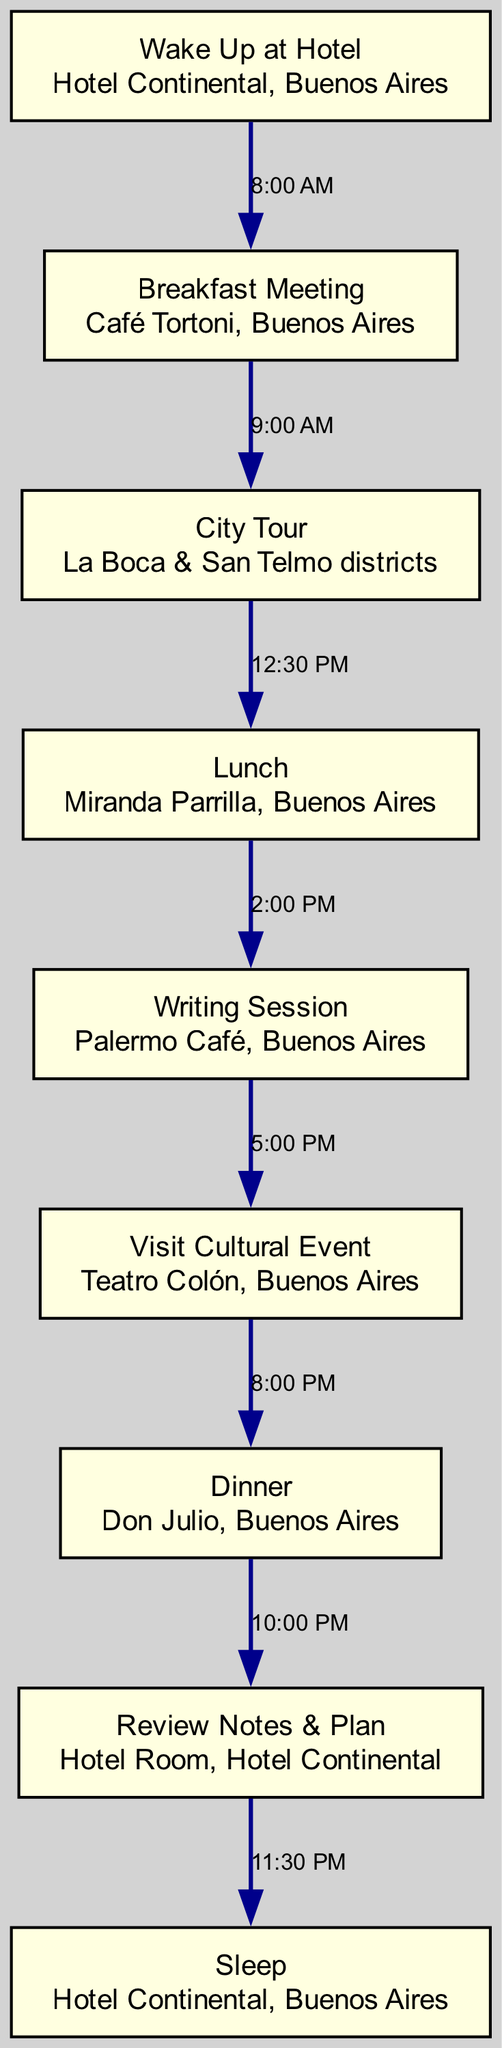What is the first activity of the day? The diagram shows the first node labeled "Wake Up at Hotel" which is the starting point of the daily itinerary.
Answer: Wake Up at Hotel What location is indicated for the breakfast meeting? The breakfast node states "Breakfast Meeting" and the location mentioned below it is "Café Tortoni, Buenos Aires."
Answer: Café Tortoni, Buenos Aires How many activities are scheduled after lunch? From the diagram, after the "Lunch" node, there are two activities: "Writing Session" and "Visit Cultural Event."
Answer: 2 What time does the writing session start? The edge connecting "Lunch" to "Writing Session" indicates that the writing session begins at "2:00 PM."
Answer: 2:00 PM What is the last activity before sleep? The last node before "Sleep" is "Review Notes & Plan," which happens after "Dinner."
Answer: Review Notes & Plan At what time does the dinner activity occur? The edge leading from "Visit Cultural Event" to "Dinner" shows the time specified as "8:00 PM."
Answer: 8:00 PM What locations are part of the morning activities? The "City Tour" node specifies the locations as "La Boca & San Telmo districts."
Answer: La Boca & San Telmo districts How does the diagram represent the relationship between lunch and the afternoon activity? The diagram uses a directed edge showing that "Lunch" leads to "Writing Session," enhancing the understanding of the itinerary flow.
Answer: Lunch leads to Writing Session What activity occurs right after the city tour? The next activity indicated by the edge connecting "City Tour" to "Lunch" directly shows that "Lunch" follows the city tour.
Answer: Lunch 